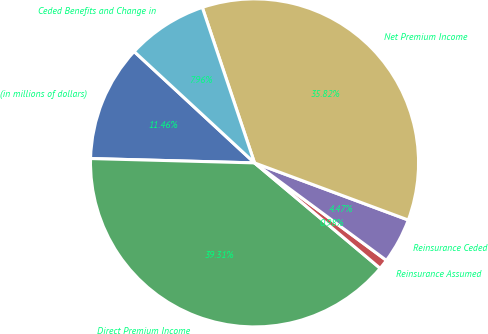Convert chart to OTSL. <chart><loc_0><loc_0><loc_500><loc_500><pie_chart><fcel>(in millions of dollars)<fcel>Direct Premium Income<fcel>Reinsurance Assumed<fcel>Reinsurance Ceded<fcel>Net Premium Income<fcel>Ceded Benefits and Change in<nl><fcel>11.46%<fcel>39.31%<fcel>0.98%<fcel>4.47%<fcel>35.82%<fcel>7.96%<nl></chart> 